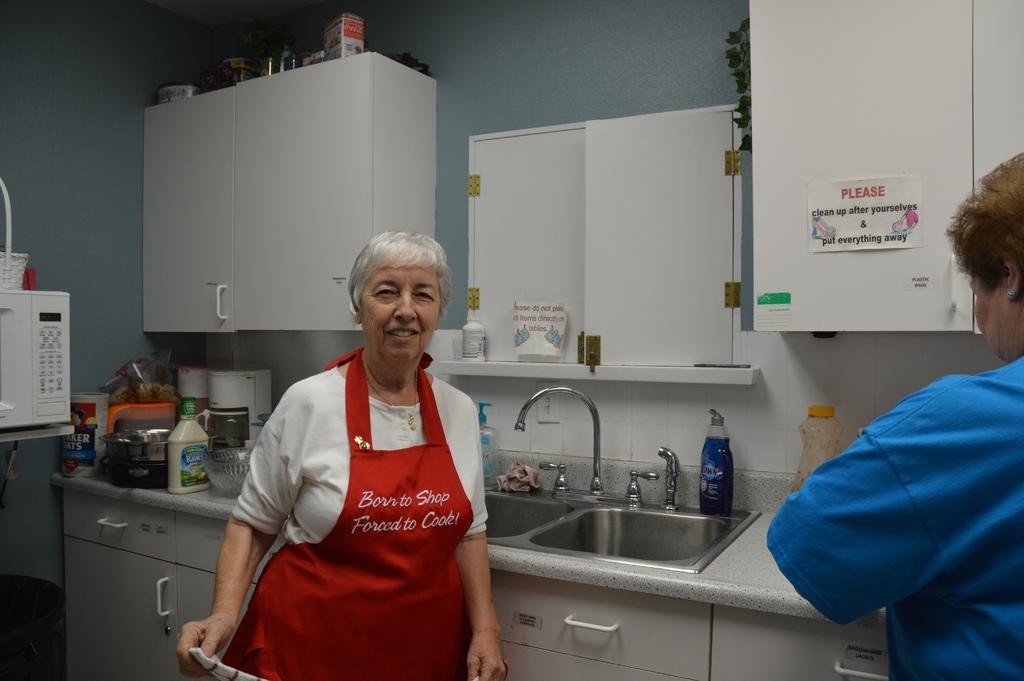<image>
Describe the image concisely. An older woman in the kitchen wearing a red apron that reads, "Born to shop, forced to cook". 